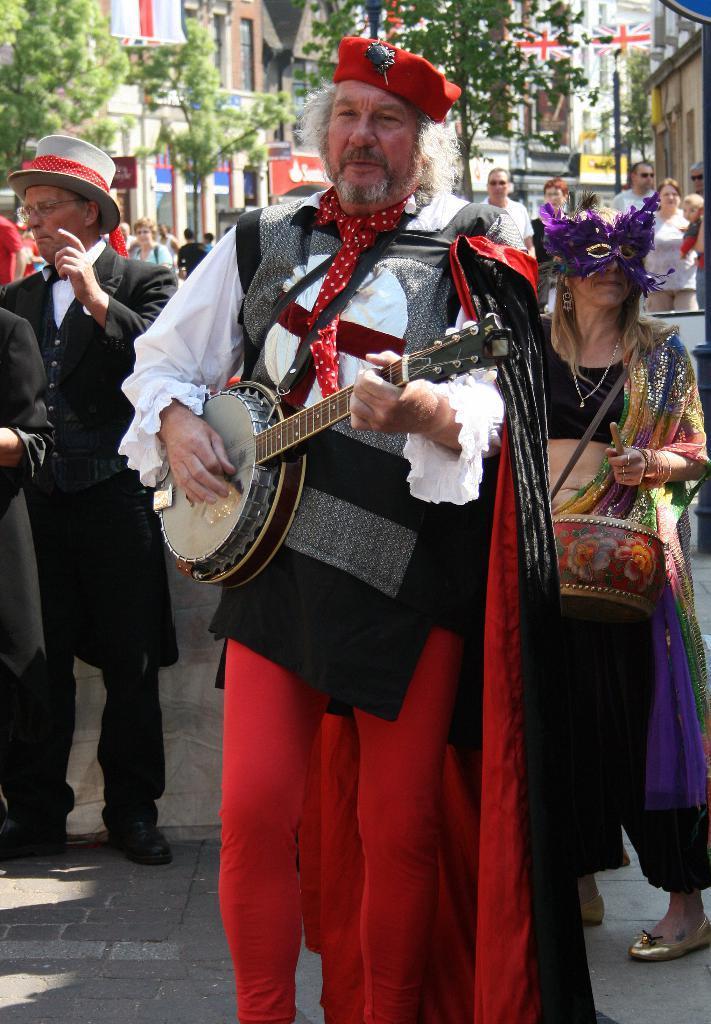Describe this image in one or two sentences. In the picture we can see some people are standing on the road with different costumes and they are playing a musical instrument and behind them we can see some trees, buildings. 